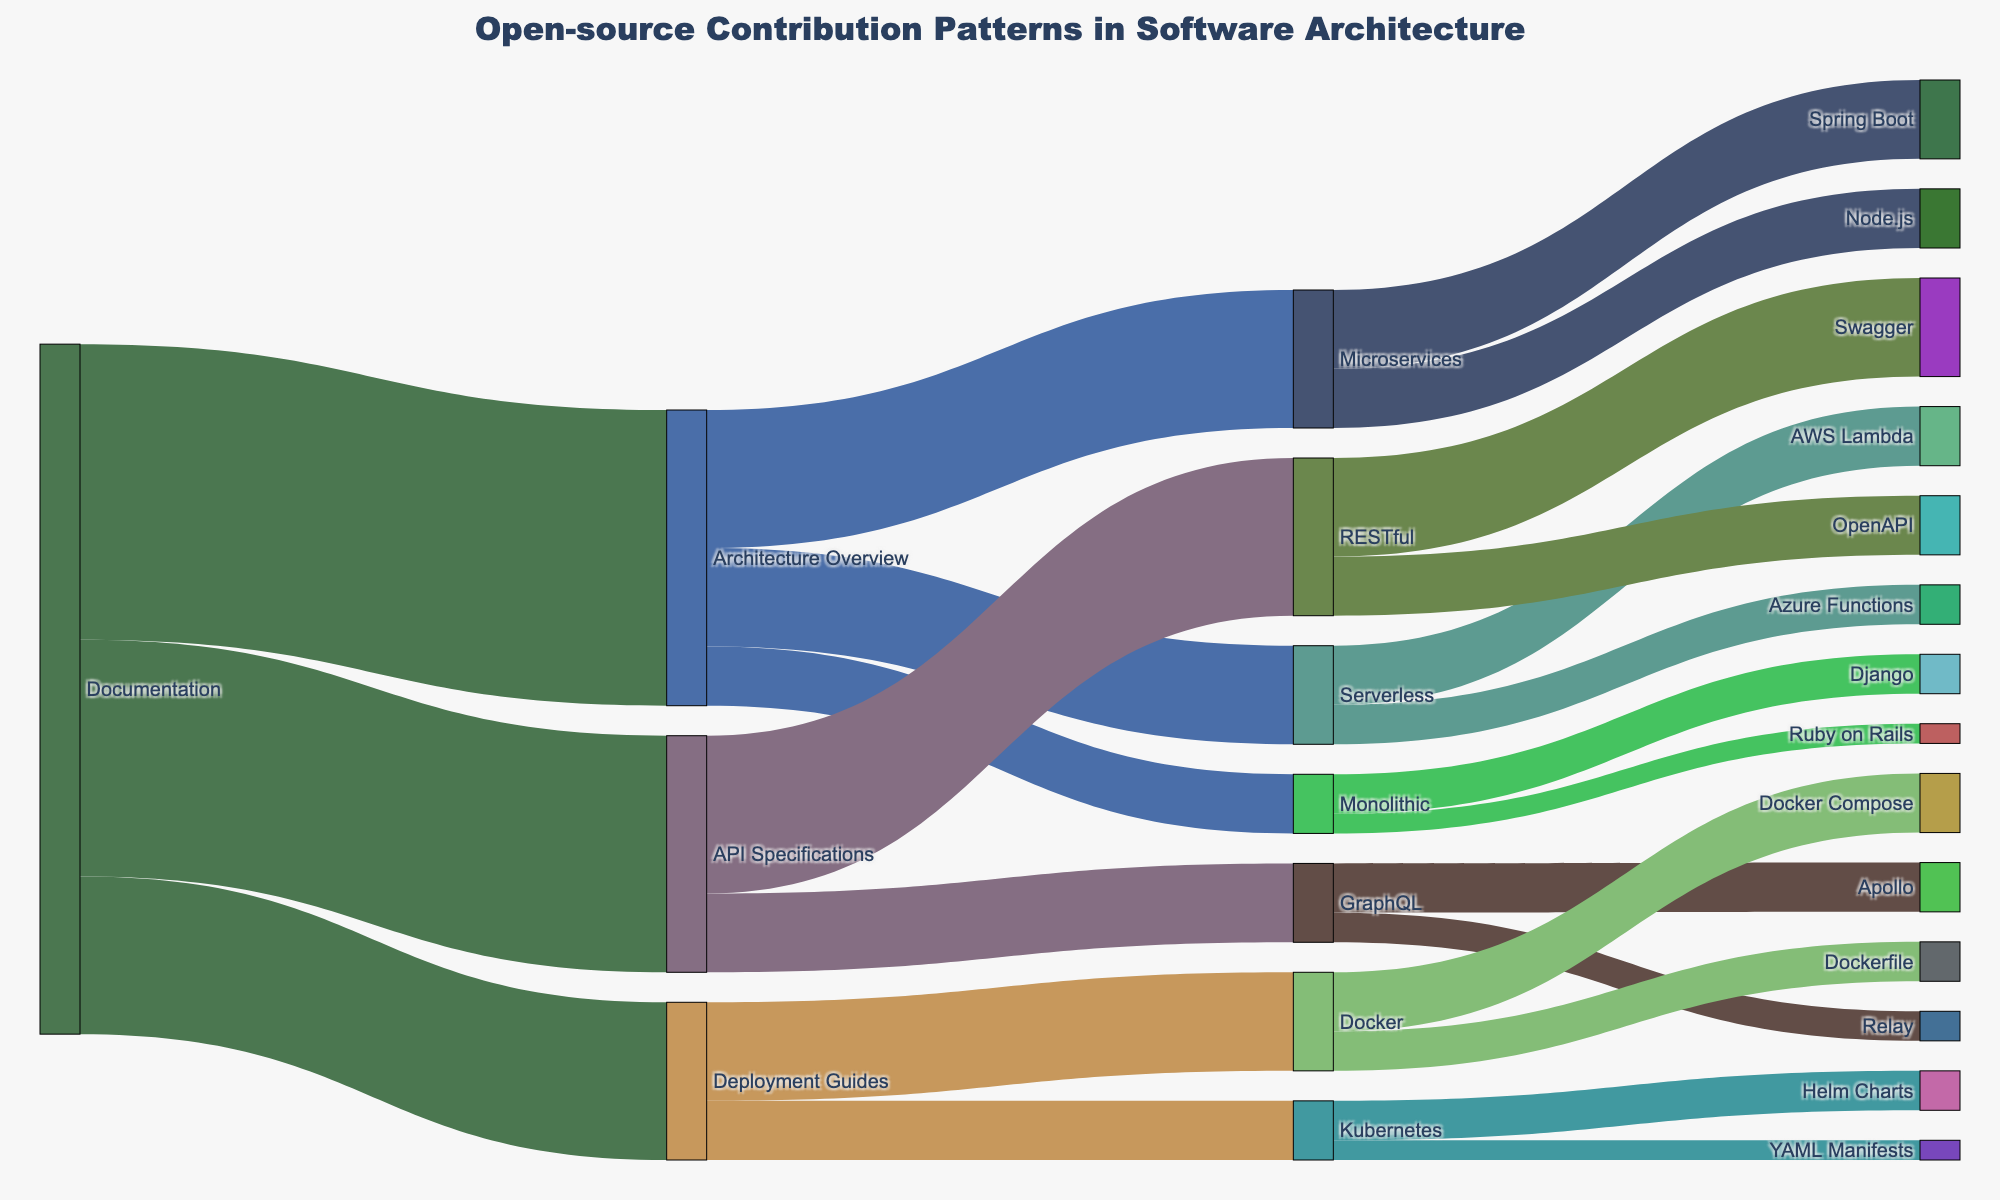What's the title of the figure? The title is typically at the top of the figure and provides an overview of what the figure represents. By looking at the top of the Sankey diagram, you can find the title "Open-source Contribution Patterns in Software Architecture".
Answer: Open-source Contribution Patterns in Software Architecture Which category has the highest contribution value in Documentation? The Sankey diagram shows the flow from Documentation to various targets. By comparing the values, Documentation to Architecture Overview has the highest value of 150.
Answer: Architecture Overview Which category has the lowest contribution value in Deployment Guides? By observing the flows from Deployment Guides to its targets in the diagram, Kubernetes has the lowest contribution value of 30.
Answer: Kubernetes What is the total value of contributions to API Specifications? To find this, sum up the contributions flowing out of API Specifications. The values are RESTful (80) and GraphQL (40), so 80 + 40 = 120.
Answer: 120 Compare the contributions to Spring Boot and Node.js under Microservices. Which has more contributions? The diagram shows the contributions to Spring Boot as 40 and to Node.js as 30. Therefore, Spring Boot has more contributions.
Answer: Spring Boot What categories does Architecture Overview contribute to and what are their values? Follow the flows originating from Architecture Overview. The categories are Microservices (70), Monolithic (30), and Serverless (50).
Answer: Microservices (70), Monolithic (30), Serverless (50) Calculate the total contributions from Monolithic. The contributions from Monolithic are to Django (20) and Ruby on Rails (10), add them together: 20 + 10 = 30.
Answer: 30 Which Serverless component receives more contributions, AWS Lambda or Azure Functions? By observing the contribution values in the diagram, AWS Lambda receives 30 and Azure Functions receives 20. AWS Lambda receives more contributions.
Answer: AWS Lambda Identify all categories that Documentation contributes to. Follow the flows from Documentation, contributing to Architecture Overview (150), API Specifications (120), and Deployment Guides (80).
Answer: Architecture Overview, API Specifications, Deployment Guides Which category receives more contributions, Docker Compose or YAML Manifests? The diagram shows that Docker Compose receives 30 contributions while YAML Manifests receives 10. Docker Compose receives more contributions.
Answer: Docker Compose 